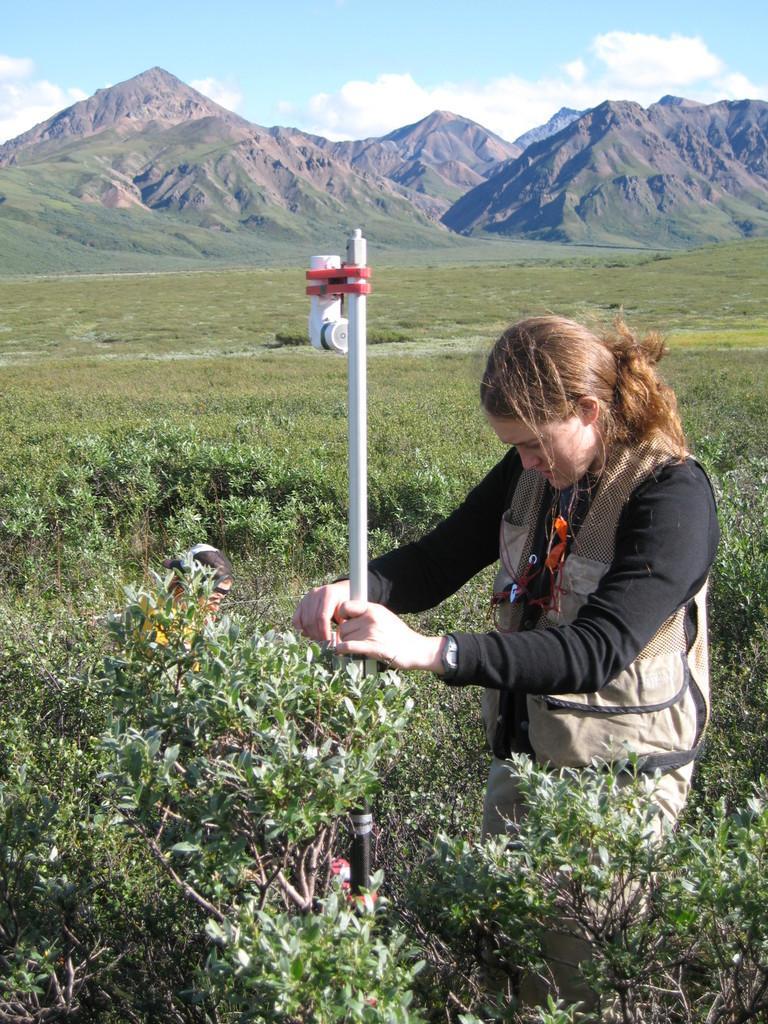Can you describe this image briefly? In the image I can see there is a lady standing in the middle and holding a pole, beside the plants there is another girl sitting also there are mountains at the back. 